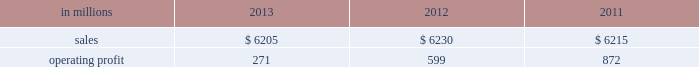Million excluding a gain on a bargain purchase price adjustment on the acquisition of a majority share of our operations in turkey and restructuring costs ) compared with $ 53 million ( $ 72 million excluding restructuring costs ) in 2012 and $ 66 million ( $ 61 million excluding a gain for a bargain purchase price adjustment on an acquisition by our then joint venture in turkey and costs associated with the closure of our etienne mill in france in 2009 ) in 2011 .
Sales volumes in 2013 were higher than in 2012 reflecting strong demand for packaging in the agricultural markets in morocco and turkey .
In europe , sales volumes decreased slightly due to continuing weak demand for packaging in the industrial markets , and lower demand for packaging in the agricultural markets resulting from poor weather conditions .
Average sales margins were significantly lower due to input costs for containerboard rising ahead of box sales price increases .
Other input costs were also higher , primarily for energy .
Operating profits in 2013 and 2012 included net gains of $ 13 million and $ 10 million , respectively , for insurance settlements and italian government grants , partially offset by additional operating costs , related to the earthquakes in northern italy in may 2012 which affected our san felice box plant .
Entering the first quarter of 2014 , sales volumes are expected to increase slightly reflecting higher demand for packaging in the industrial markets .
Average sales margins are expected to gradually improve as a result of slight reductions in material costs and planned box price increases .
Other input costs should be about flat .
Brazilian industrial packaging includes the results of orsa international paper embalagens s.a. , a corrugated packaging producer in which international paper acquired a 75% ( 75 % ) share in january 2013 .
Net sales were $ 335 million in 2013 .
Operating profits in 2013 were a loss of $ 2 million ( a gain of $ 2 million excluding acquisition and integration costs ) .
Looking ahead to the first quarter of 2014 , sales volumes are expected to be seasonally lower than in the fourth quarter of 2013 .
Average sales margins should improve reflecting the partial implementation of an announced sales price increase and a more favorable product mix .
Operating costs and input costs are expected to be lower .
Asian industrial packaging net sales were $ 400 million in 2013 compared with $ 400 million in 2012 and $ 410 million in 2011 .
Operating profits for the packaging operations were a loss of $ 5 million in 2013 ( a loss of $ 1 million excluding restructuring costs ) compared with gains of $ 2 million in 2012 and $ 2 million in 2011 .
Operating profits were favorably impacted in 2013 by higher average sales margins and slightly higher sales volumes compared with 2012 , but these benefits were offset by higher operating costs .
Looking ahead to the first quarter of 2014 , sales volumes and average sales margins are expected to be seasonally soft .
Net sales for the distribution operations were $ 285 million in 2013 compared with $ 260 million in 2012 and $ 285 million in 2011 .
Operating profits were $ 3 million in 2013 , 2012 and 2011 .
Printing papers demand for printing papers products is closely correlated with changes in commercial printing and advertising activity , direct mail volumes and , for uncoated cut-size products , with changes in white- collar employment levels that affect the usage of copy and laser printer paper .
Pulp is further affected by changes in currency rates that can enhance or disadvantage producers in different geographic regions .
Principal cost drivers include manufacturing efficiency , raw material and energy costs and freight costs .
Printing papers net sales for 2013 were about flat with both 2012 and 2011 .
Operating profits in 2013 were 55% ( 55 % ) lower than in 2012 and 69% ( 69 % ) lower than in 2011 .
Excluding facility closure costs and impairment costs , operating profits in 2013 were 15% ( 15 % ) lower than in 2012 and 40% ( 40 % ) lower than in 2011 .
Benefits from lower operating costs ( $ 81 million ) and lower maintenance outage costs ( $ 17 million ) were more than offset by lower average sales price realizations ( $ 38 million ) , lower sales volumes ( $ 14 million ) , higher input costs ( $ 99 million ) and higher other costs ( $ 34 million ) .
In addition , operating profits in 2013 included costs of $ 118 million associated with the announced closure of our courtland , alabama mill .
During 2013 , the company accelerated depreciation for certain courtland assets , and diligently evaluated certain other assets for possible alternative uses by one of our other businesses .
The net book value of these assets at december 31 , 2013 was approximately $ 470 million .
During 2014 , we have continued our evaluation and expect to conclude as to any uses for these assets during the first quarter of 2014 .
Operating profits also included a $ 123 million impairment charge associated with goodwill and a trade name intangible asset in our india papers business .
Operating profits in 2011 included a $ 24 million gain related to the announced repurposing of our franklin , virginia mill to produce fluff pulp and an $ 11 million impairment charge related to our inverurie , scotland mill that was closed in 2009 .
Printing papers .
North american printing papers net sales were $ 2.6 billion in 2013 , $ 2.7 billion in 2012 and $ 2.8 billion in 2011. .
In 2013 what percentage of printing papers sales where attributable to north american printing papers net sales? 
Computations: ((2.6 * 1000) / 6205)
Answer: 0.41902. 